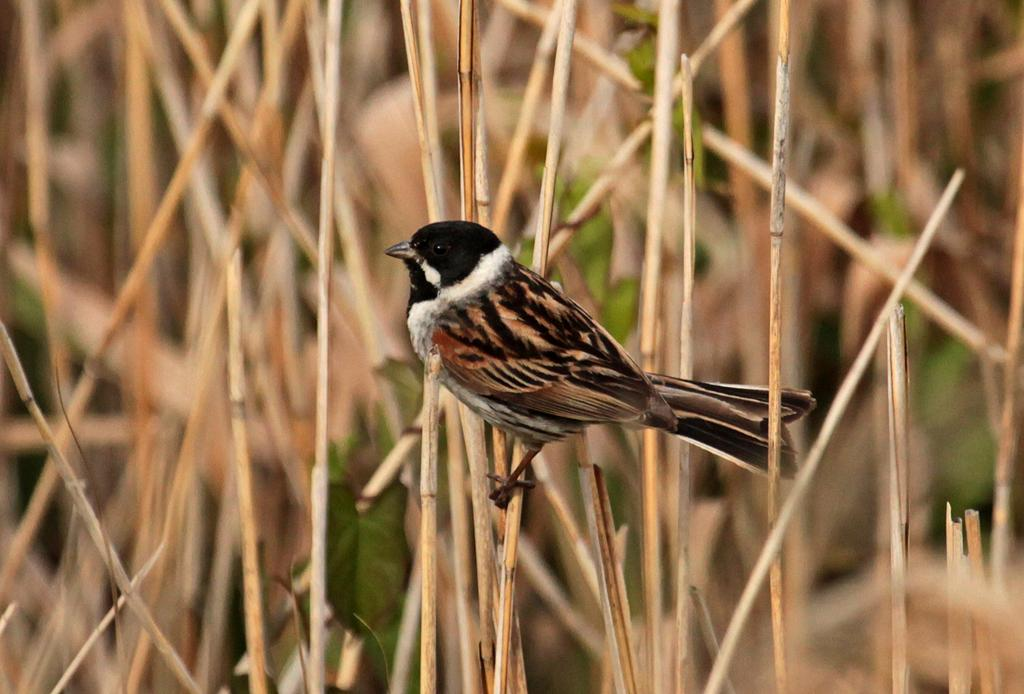What type of animal can be seen in the image? There is a bird in the image. What is the bird standing on? The bird is standing on dry sticks. What type of scissors is the bird using to cut the key in the image? There is no scissors or key present in the image; it only features a bird standing on dry sticks. 